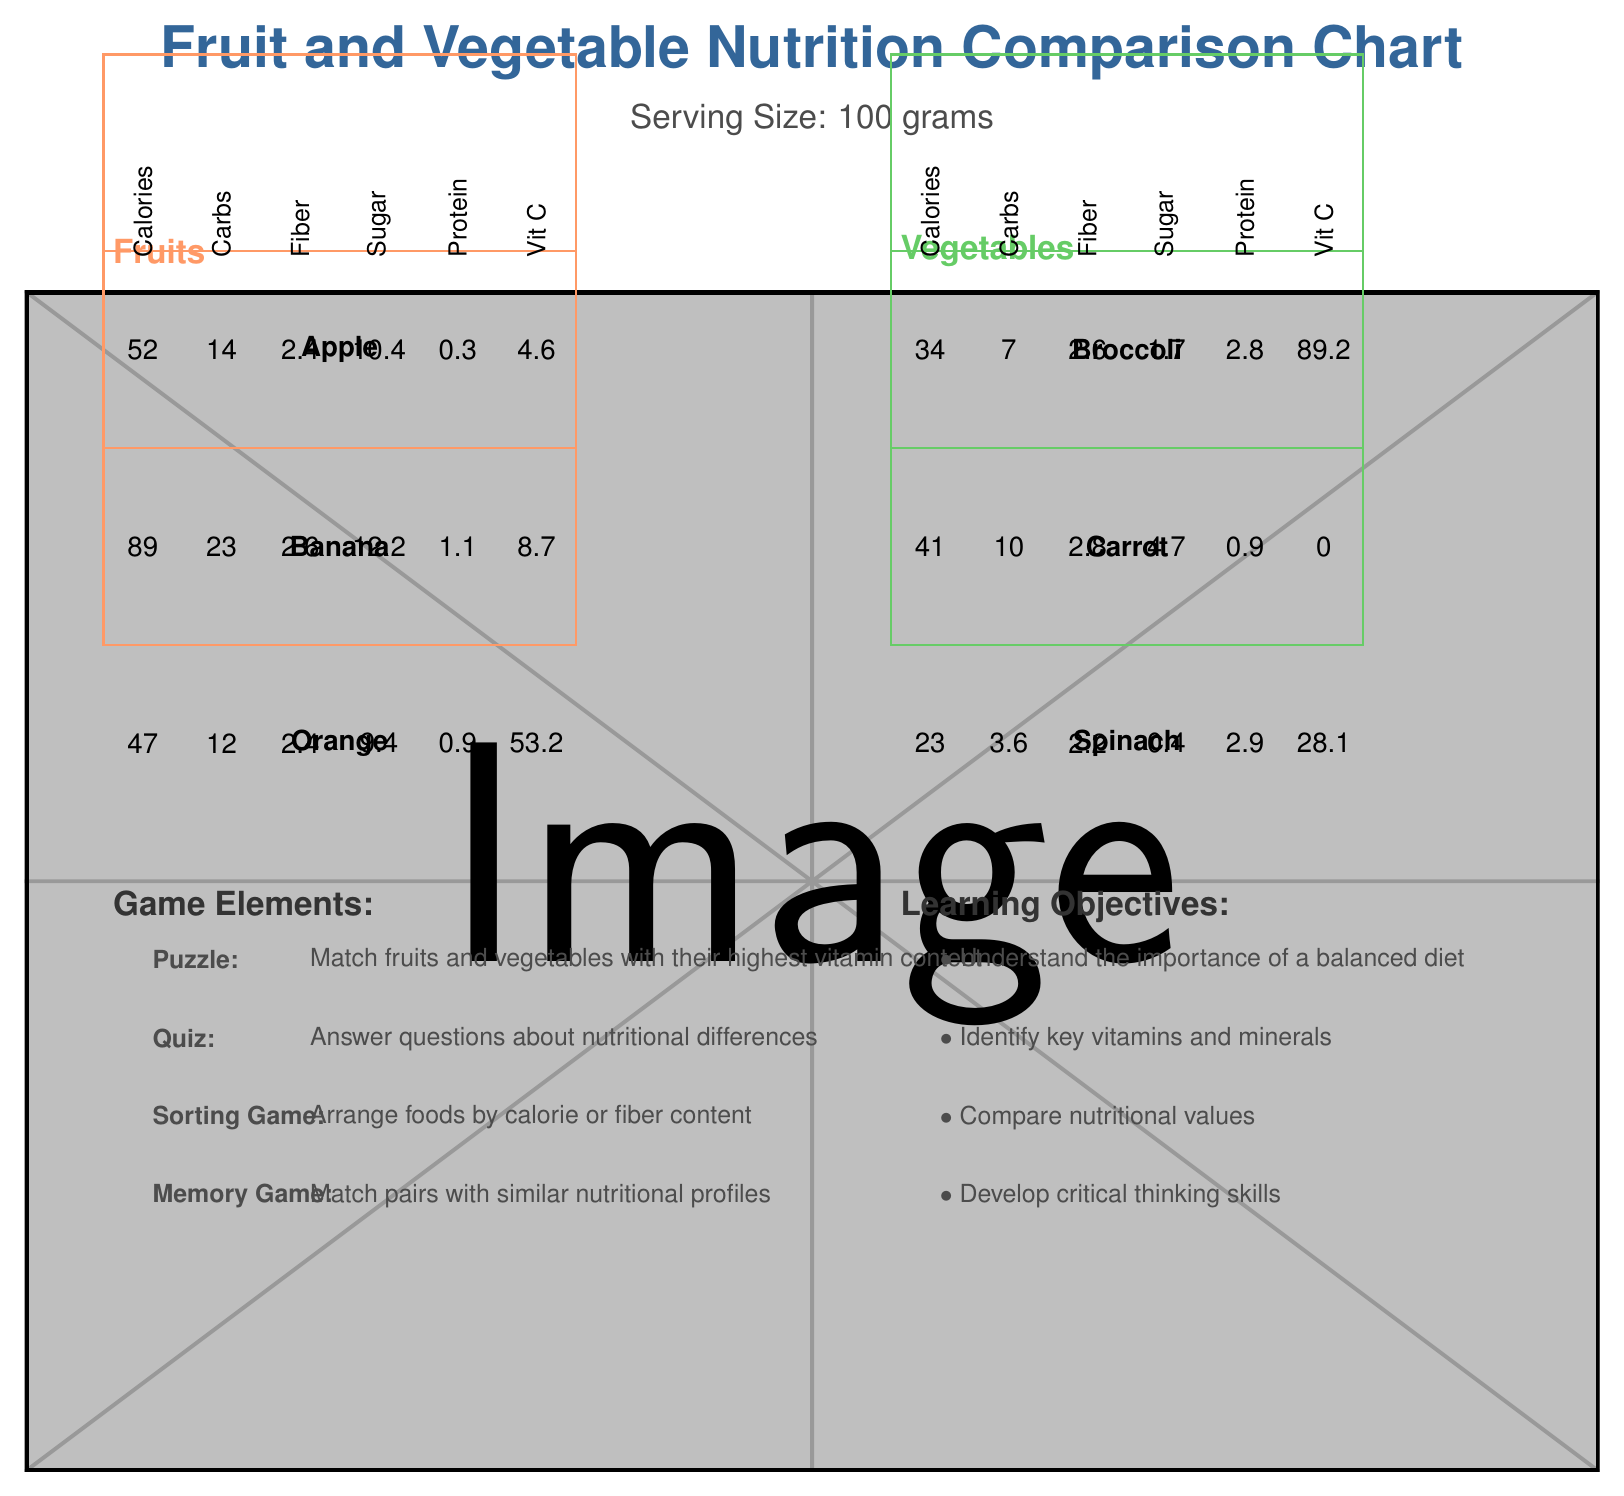What is the serving size mentioned in the document? The serving size is clearly stated in the document as "Serving Size: 100 grams".
Answer: 100 grams Which fruit has the highest calorie content? Based on the document, the calorie content for Banana is 89, which is higher than that of Apple (52) and Orange (47).
Answer: Banana Which vegetable contains the most Vitamin C? The document indicates that Broccoli contains 89.2 mg of Vitamin C, which is higher than Carrot (0 mg) and Spinach (28.1 mg).
Answer: Broccoli Name one of the game elements described in the document. The document lists several game elements: Puzzle, Quiz, Sorting Game, Memory Game.
Answer: Puzzle What fruit has the highest Dietary Fiber content among the listed fruits? Banana has 2.6 grams of Dietary Fiber, which is higher than both Apple (2.4 grams) and Orange (2.4 grams).
Answer: Banana Which vegetable has the lowest sugar content? A. Broccoli B. Carrot C. Spinach Spinach has 0.4 grams of sugar, while Broccoli has 1.7 grams, and Carrot has 4.7 grams.
Answer: C. Spinach Which fruit contains the most Vitamin C? 1. Apple 2. Banana 3. Orange The document shows that Orange has 53.2 mg of Vitamin C, which is higher than Apple (4.6 mg) and Banana (8.7 mg).
Answer: 3. Orange Is Broccoli a source of Vitamin K? The document lists Vitamin K in Broccoli with a value of 101.6 μg.
Answer: Yes Summarize the main purpose of the document. The document serves as an educational tool, comparing nutrients like Vitamins, Calories, Fiber in fruits and vegetables, and incorporates engaging game elements to teach children about nutrition.
Answer: The document aims to provide a comparison of the nutritional content of various fruits and vegetables, alongside game elements and learning objectives that facilitate understanding of healthy eating and the importance of vitamins and minerals. Which vegetable has the highest iron content? The document does not provide iron content for Broccoli and Carrot, so we cannot determine which vegetable has the highest iron content.
Answer: Not enough information 